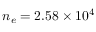Convert formula to latex. <formula><loc_0><loc_0><loc_500><loc_500>n _ { e } = 2 . 5 8 \times 1 0 ^ { 4 }</formula> 